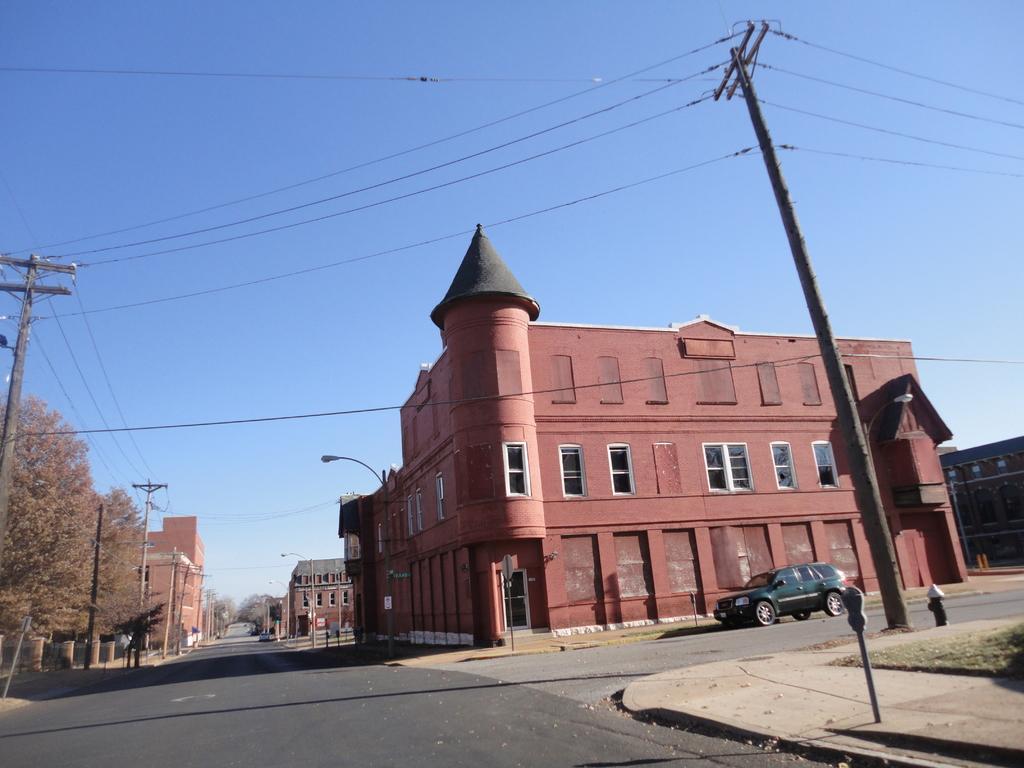Describe this image in one or two sentences. In this image there is a road in the bottom of this image and there are some buildings in the background. There is a car on the right side of this image and there are some trees on the left side of this image. There is a sky on the top of this image. There are some current polls on the right side of this image and left side of this image as well. 